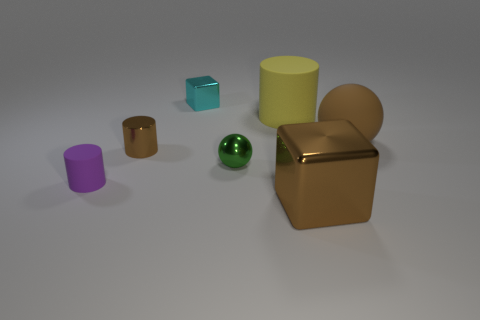What materials do these objects seem to be made of? The objects appear to be made of different materials with metallic finishes. The green sphere and the gold cube might be made of polished metals, while the others seem to have a matte or slightly reflective plastic finish. 